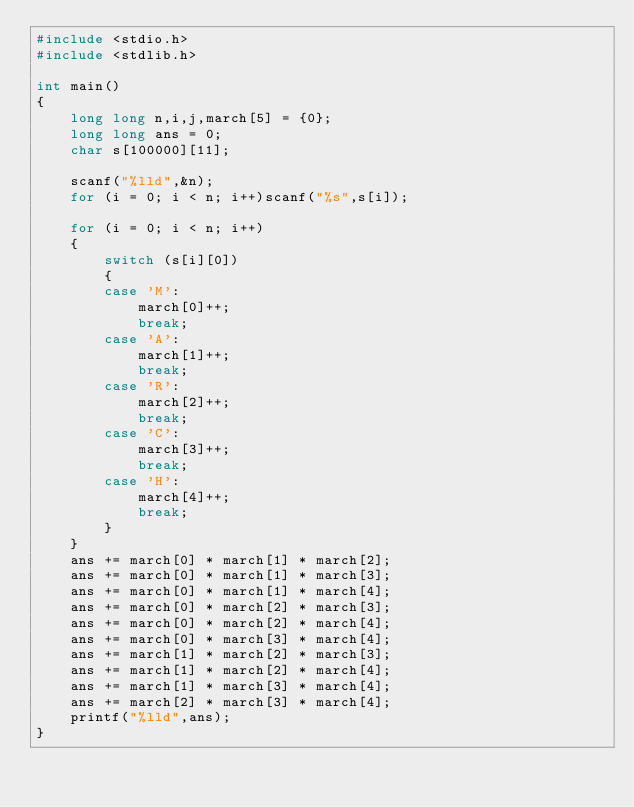Convert code to text. <code><loc_0><loc_0><loc_500><loc_500><_C_>#include <stdio.h>
#include <stdlib.h>

int main()
{
    long long n,i,j,march[5] = {0};
    long long ans = 0;
    char s[100000][11];

    scanf("%lld",&n);
    for (i = 0; i < n; i++)scanf("%s",s[i]);

    for (i = 0; i < n; i++)
    {
        switch (s[i][0])
        {
        case 'M':
            march[0]++;
            break;
        case 'A':
            march[1]++;
            break;
        case 'R':
            march[2]++;
            break;
        case 'C':
            march[3]++;
            break;
        case 'H':
            march[4]++;
            break;
        }
    }
    ans += march[0] * march[1] * march[2];
    ans += march[0] * march[1] * march[3];
    ans += march[0] * march[1] * march[4];
    ans += march[0] * march[2] * march[3];
    ans += march[0] * march[2] * march[4];
    ans += march[0] * march[3] * march[4];
    ans += march[1] * march[2] * march[3];
    ans += march[1] * march[2] * march[4];
    ans += march[1] * march[3] * march[4];
    ans += march[2] * march[3] * march[4];
    printf("%lld",ans);
}</code> 